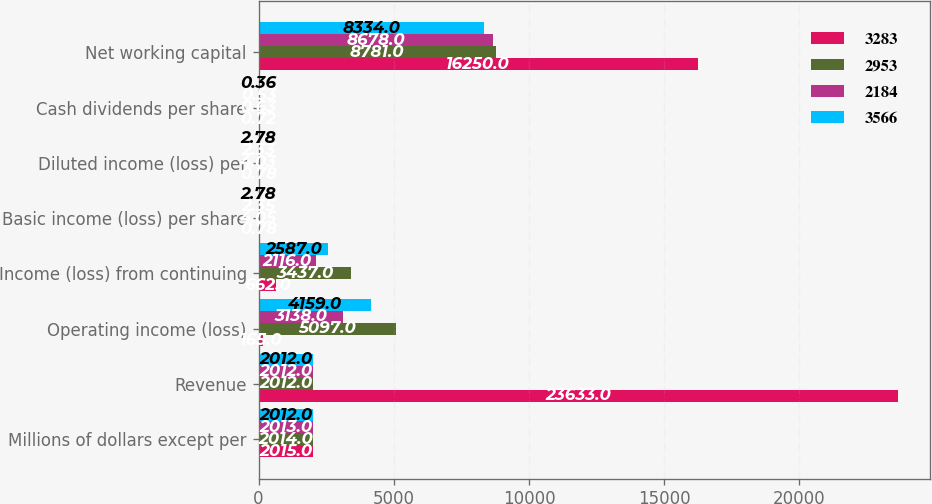<chart> <loc_0><loc_0><loc_500><loc_500><stacked_bar_chart><ecel><fcel>Millions of dollars except per<fcel>Revenue<fcel>Operating income (loss)<fcel>Income (loss) from continuing<fcel>Basic income (loss) per share<fcel>Diluted income (loss) per<fcel>Cash dividends per share<fcel>Net working capital<nl><fcel>3283<fcel>2015<fcel>23633<fcel>165<fcel>662<fcel>0.78<fcel>0.78<fcel>0.72<fcel>16250<nl><fcel>2953<fcel>2014<fcel>2012<fcel>5097<fcel>3437<fcel>4.05<fcel>4.03<fcel>0.63<fcel>8781<nl><fcel>2184<fcel>2013<fcel>2012<fcel>3138<fcel>2116<fcel>2.35<fcel>2.33<fcel>0.53<fcel>8678<nl><fcel>3566<fcel>2012<fcel>2012<fcel>4159<fcel>2587<fcel>2.78<fcel>2.78<fcel>0.36<fcel>8334<nl></chart> 